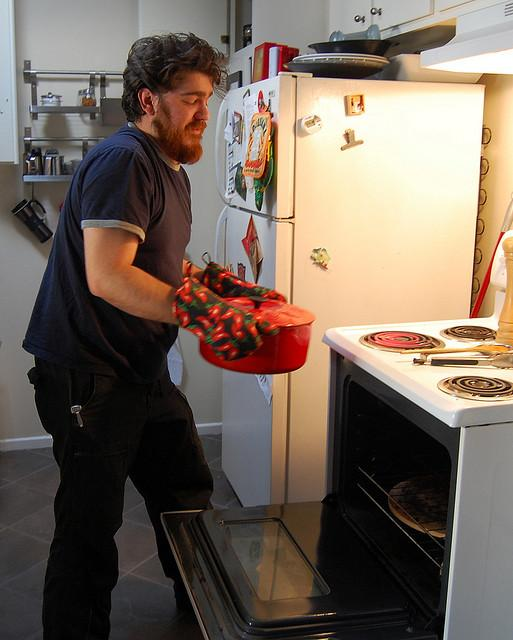What allows him to see the contents of the oven when the door is closed? Please explain your reasoning. window. The oven has a window allowing visibility to its contents. 